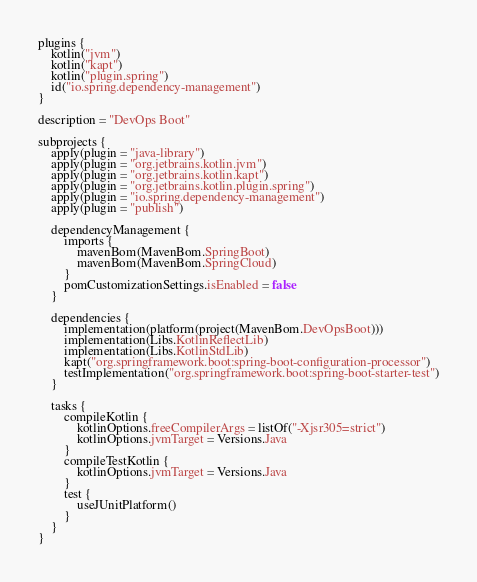<code> <loc_0><loc_0><loc_500><loc_500><_Kotlin_>plugins {
    kotlin("jvm")
    kotlin("kapt")
    kotlin("plugin.spring")
    id("io.spring.dependency-management")
}

description = "DevOps Boot"

subprojects {
    apply(plugin = "java-library")
    apply(plugin = "org.jetbrains.kotlin.jvm")
    apply(plugin = "org.jetbrains.kotlin.kapt")
    apply(plugin = "org.jetbrains.kotlin.plugin.spring")
    apply(plugin = "io.spring.dependency-management")
    apply(plugin = "publish")

    dependencyManagement {
        imports {
            mavenBom(MavenBom.SpringBoot)
            mavenBom(MavenBom.SpringCloud)
        }
        pomCustomizationSettings.isEnabled = false
    }

    dependencies {
        implementation(platform(project(MavenBom.DevOpsBoot)))
        implementation(Libs.KotlinReflectLib)
        implementation(Libs.KotlinStdLib)
        kapt("org.springframework.boot:spring-boot-configuration-processor")
        testImplementation("org.springframework.boot:spring-boot-starter-test")
    }

    tasks {
        compileKotlin {
            kotlinOptions.freeCompilerArgs = listOf("-Xjsr305=strict")
            kotlinOptions.jvmTarget = Versions.Java
        }
        compileTestKotlin {
            kotlinOptions.jvmTarget = Versions.Java
        }
        test {
            useJUnitPlatform()
        }
    }
}
</code> 